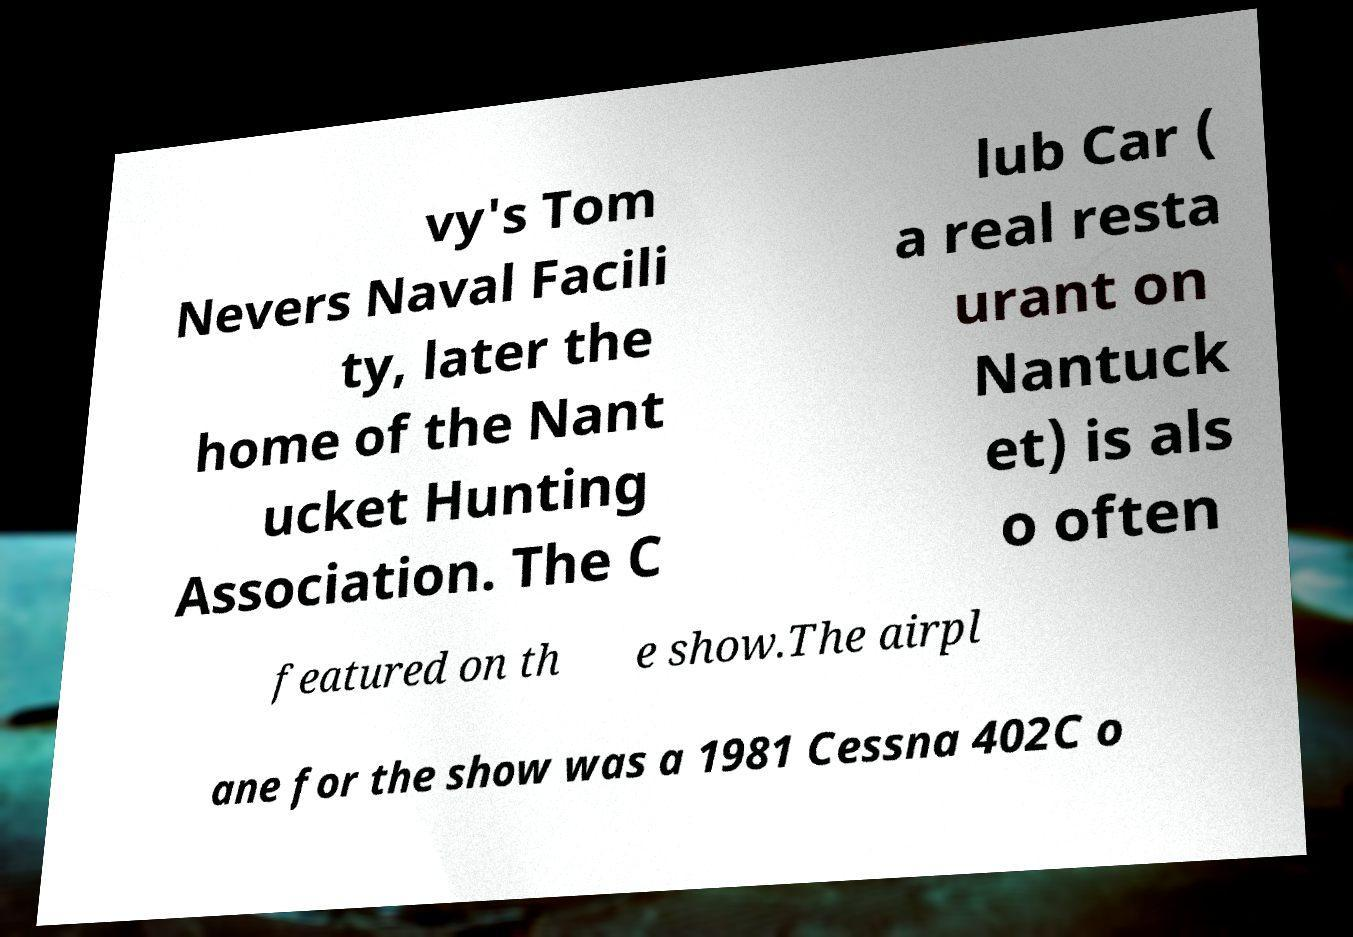For documentation purposes, I need the text within this image transcribed. Could you provide that? vy's Tom Nevers Naval Facili ty, later the home of the Nant ucket Hunting Association. The C lub Car ( a real resta urant on Nantuck et) is als o often featured on th e show.The airpl ane for the show was a 1981 Cessna 402C o 